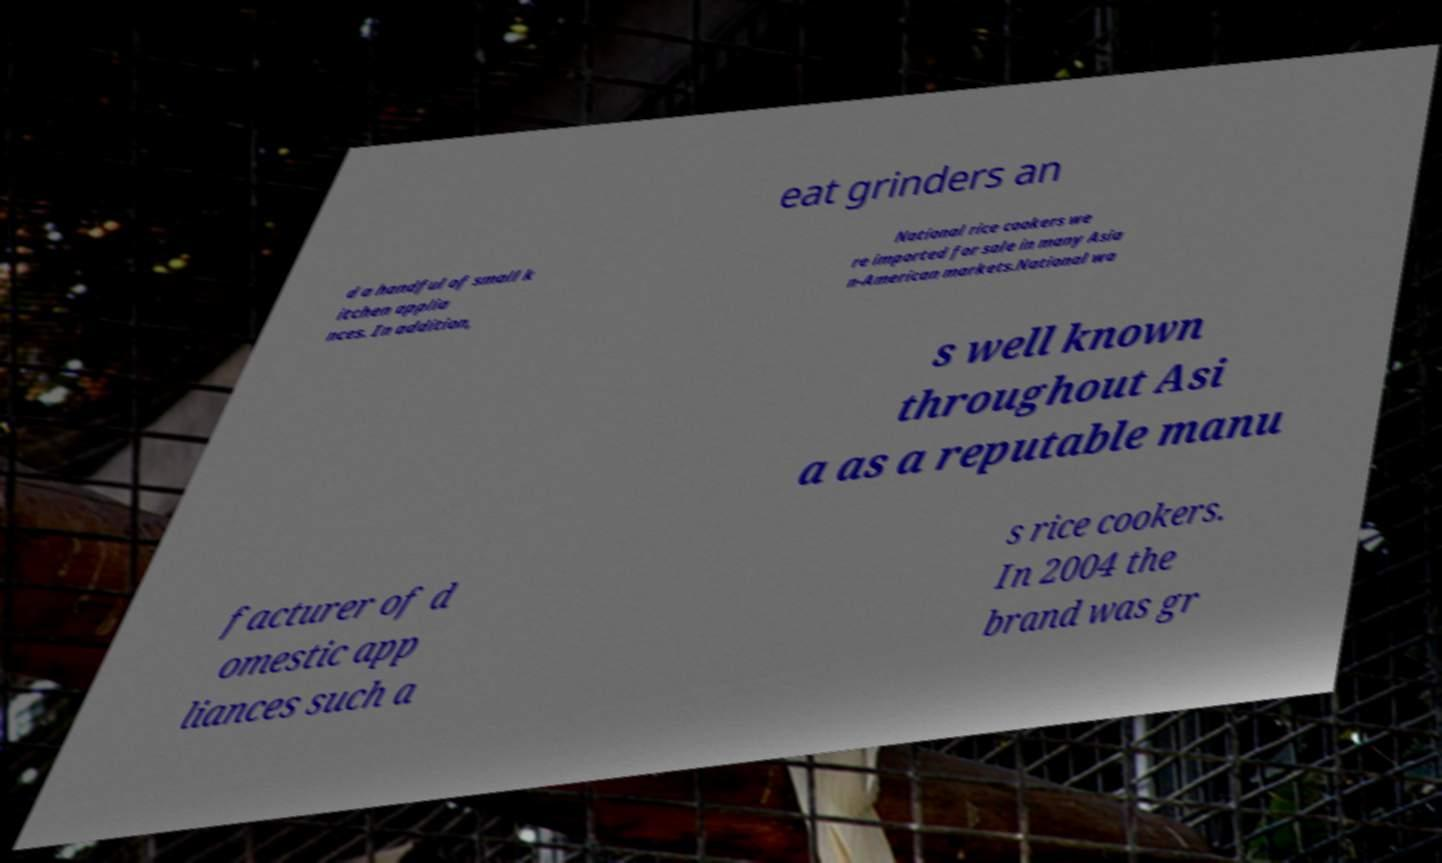For documentation purposes, I need the text within this image transcribed. Could you provide that? eat grinders an d a handful of small k itchen applia nces. In addition, National rice cookers we re imported for sale in many Asia n-American markets.National wa s well known throughout Asi a as a reputable manu facturer of d omestic app liances such a s rice cookers. In 2004 the brand was gr 